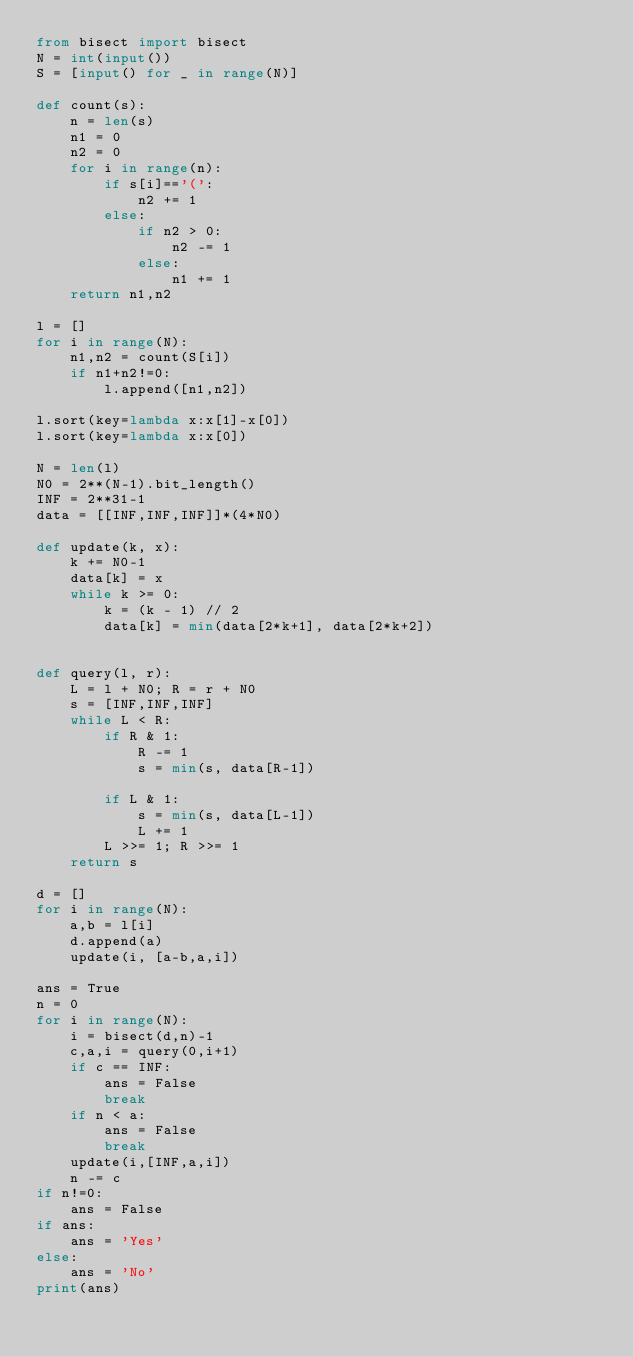<code> <loc_0><loc_0><loc_500><loc_500><_Python_>from bisect import bisect
N = int(input())
S = [input() for _ in range(N)]

def count(s):
    n = len(s)
    n1 = 0
    n2 = 0
    for i in range(n):
        if s[i]=='(':
            n2 += 1
        else:
            if n2 > 0:
                n2 -= 1
            else:
                n1 += 1
    return n1,n2

l = []
for i in range(N):
    n1,n2 = count(S[i])
    if n1+n2!=0:
        l.append([n1,n2])

l.sort(key=lambda x:x[1]-x[0])
l.sort(key=lambda x:x[0])

N = len(l)
N0 = 2**(N-1).bit_length()
INF = 2**31-1
data = [[INF,INF,INF]]*(4*N0)

def update(k, x):
    k += N0-1
    data[k] = x
    while k >= 0:
        k = (k - 1) // 2
        data[k] = min(data[2*k+1], data[2*k+2])


def query(l, r):
    L = l + N0; R = r + N0
    s = [INF,INF,INF]
    while L < R:
        if R & 1:
            R -= 1
            s = min(s, data[R-1])

        if L & 1:
            s = min(s, data[L-1])
            L += 1
        L >>= 1; R >>= 1
    return s

d = []
for i in range(N):    
    a,b = l[i]
    d.append(a)
    update(i, [a-b,a,i])

ans = True
n = 0
for i in range(N):
    i = bisect(d,n)-1
    c,a,i = query(0,i+1)
    if c == INF:
        ans = False
        break
    if n < a:
        ans = False
        break
    update(i,[INF,a,i])
    n -= c
if n!=0:
    ans = False
if ans:
    ans = 'Yes'
else:
    ans = 'No'
print(ans)</code> 